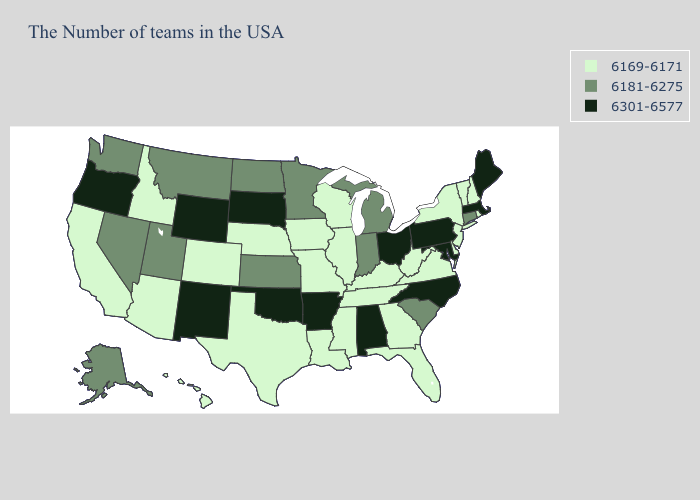Among the states that border New York , which have the lowest value?
Give a very brief answer. Vermont, New Jersey. Name the states that have a value in the range 6181-6275?
Keep it brief. Connecticut, South Carolina, Michigan, Indiana, Minnesota, Kansas, North Dakota, Utah, Montana, Nevada, Washington, Alaska. Which states have the lowest value in the Northeast?
Answer briefly. Rhode Island, New Hampshire, Vermont, New York, New Jersey. What is the highest value in states that border Maryland?
Be succinct. 6301-6577. Among the states that border Ohio , does Indiana have the lowest value?
Short answer required. No. Does Rhode Island have a higher value than Illinois?
Give a very brief answer. No. What is the value of Kentucky?
Write a very short answer. 6169-6171. Which states hav the highest value in the MidWest?
Answer briefly. Ohio, South Dakota. Does the first symbol in the legend represent the smallest category?
Write a very short answer. Yes. Name the states that have a value in the range 6169-6171?
Keep it brief. Rhode Island, New Hampshire, Vermont, New York, New Jersey, Delaware, Virginia, West Virginia, Florida, Georgia, Kentucky, Tennessee, Wisconsin, Illinois, Mississippi, Louisiana, Missouri, Iowa, Nebraska, Texas, Colorado, Arizona, Idaho, California, Hawaii. Does the map have missing data?
Answer briefly. No. What is the highest value in the USA?
Write a very short answer. 6301-6577. Does Utah have the highest value in the West?
Write a very short answer. No. Name the states that have a value in the range 6169-6171?
Keep it brief. Rhode Island, New Hampshire, Vermont, New York, New Jersey, Delaware, Virginia, West Virginia, Florida, Georgia, Kentucky, Tennessee, Wisconsin, Illinois, Mississippi, Louisiana, Missouri, Iowa, Nebraska, Texas, Colorado, Arizona, Idaho, California, Hawaii. Among the states that border Washington , which have the highest value?
Be succinct. Oregon. 